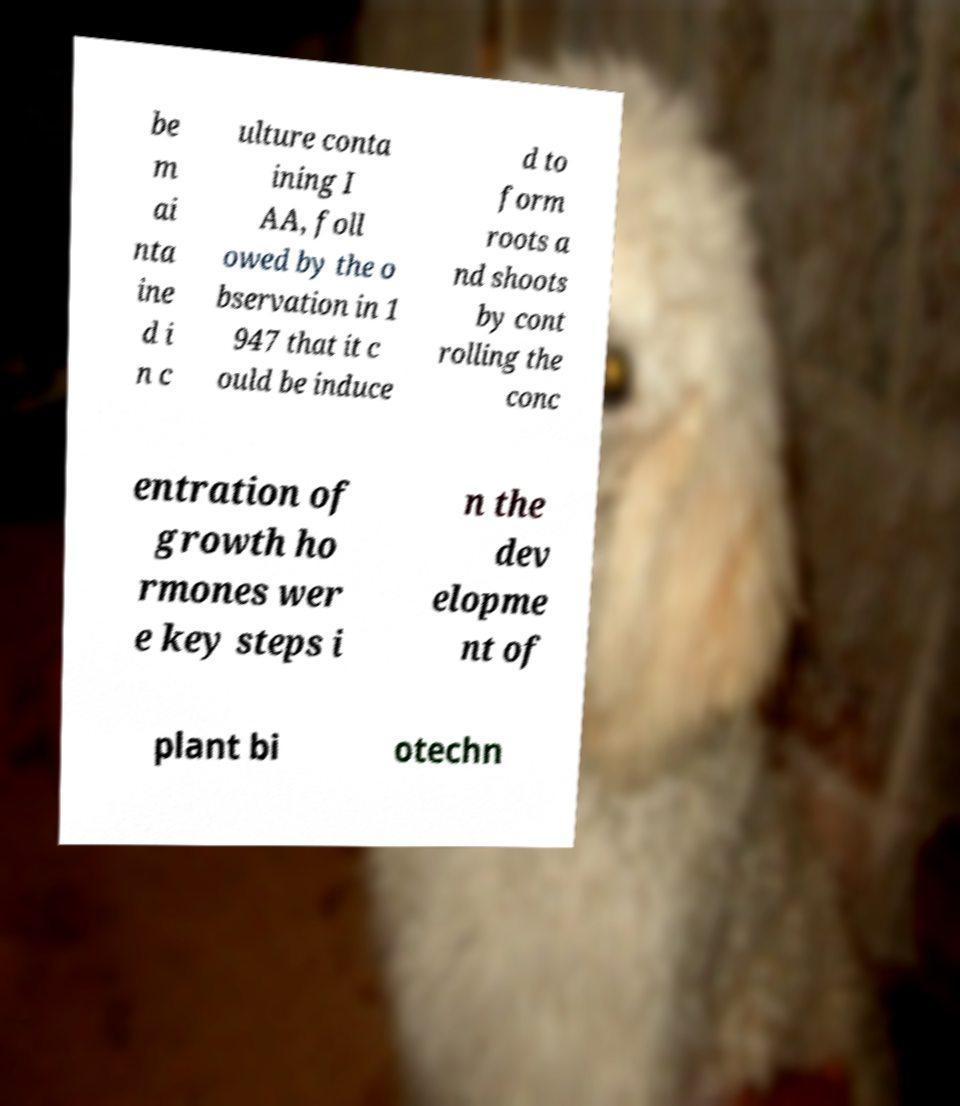Could you extract and type out the text from this image? be m ai nta ine d i n c ulture conta ining I AA, foll owed by the o bservation in 1 947 that it c ould be induce d to form roots a nd shoots by cont rolling the conc entration of growth ho rmones wer e key steps i n the dev elopme nt of plant bi otechn 